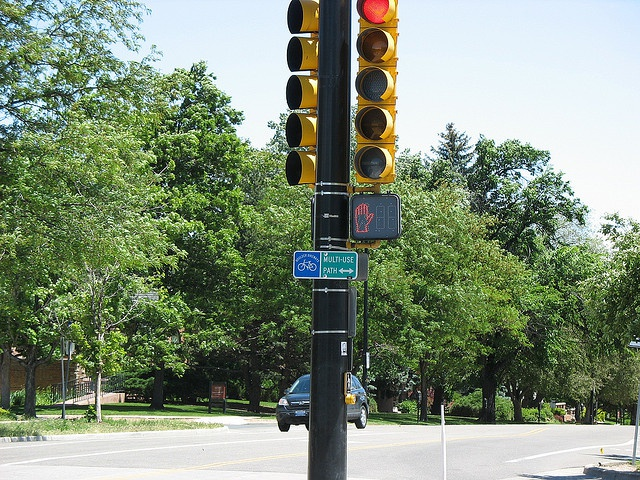Describe the objects in this image and their specific colors. I can see traffic light in olive, black, white, and orange tones, traffic light in olive, black, and white tones, and car in olive, black, gray, blue, and white tones in this image. 